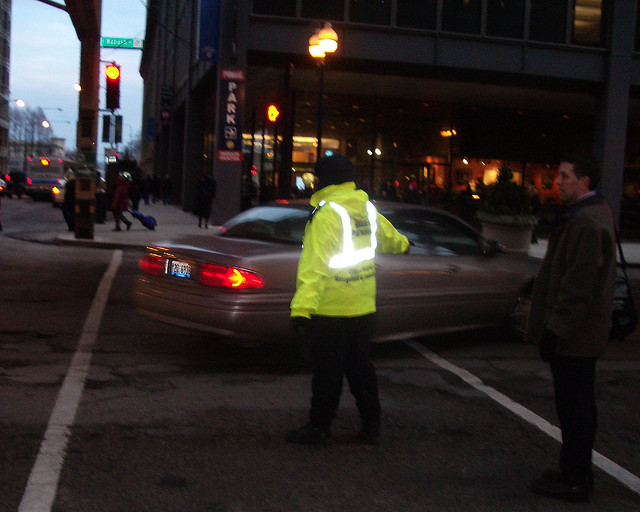Identify the text displayed in this image. PARK 